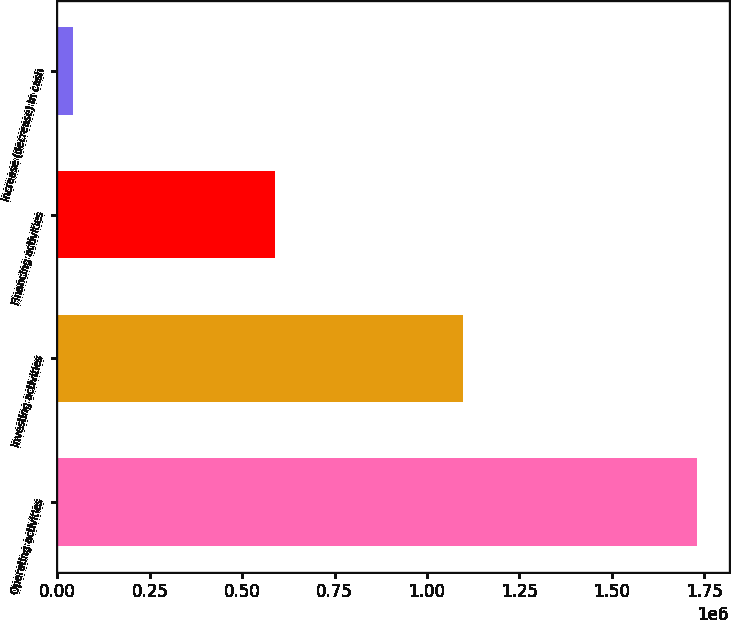Convert chart to OTSL. <chart><loc_0><loc_0><loc_500><loc_500><bar_chart><fcel>Operating activities<fcel>Investing activities<fcel>Financing activities<fcel>Increase (decrease) in cash<nl><fcel>1.73031e+06<fcel>1.09834e+06<fcel>588880<fcel>43087<nl></chart> 